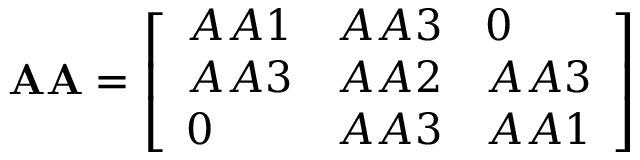<formula> <loc_0><loc_0><loc_500><loc_500>A A = { \left [ \begin{array} { l l l } { A A 1 } & { A A 3 } & { 0 } \\ { A A 3 } & { A A 2 } & { A A 3 } \\ { 0 } & { A A 3 } & { A A 1 } \end{array} \right ] }</formula> 